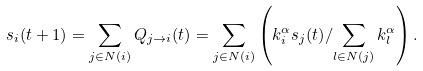Convert formula to latex. <formula><loc_0><loc_0><loc_500><loc_500>s _ { i } ( t + 1 ) = \sum _ { j \in N ( i ) } Q _ { j \rightarrow i } ( t ) & = \sum _ { j \in N ( i ) } \left ( { k ^ { \alpha } _ { i } s _ { j } ( t ) } / { \sum _ { l \in N ( j ) } k ^ { \alpha } _ { l } } \right ) .</formula> 